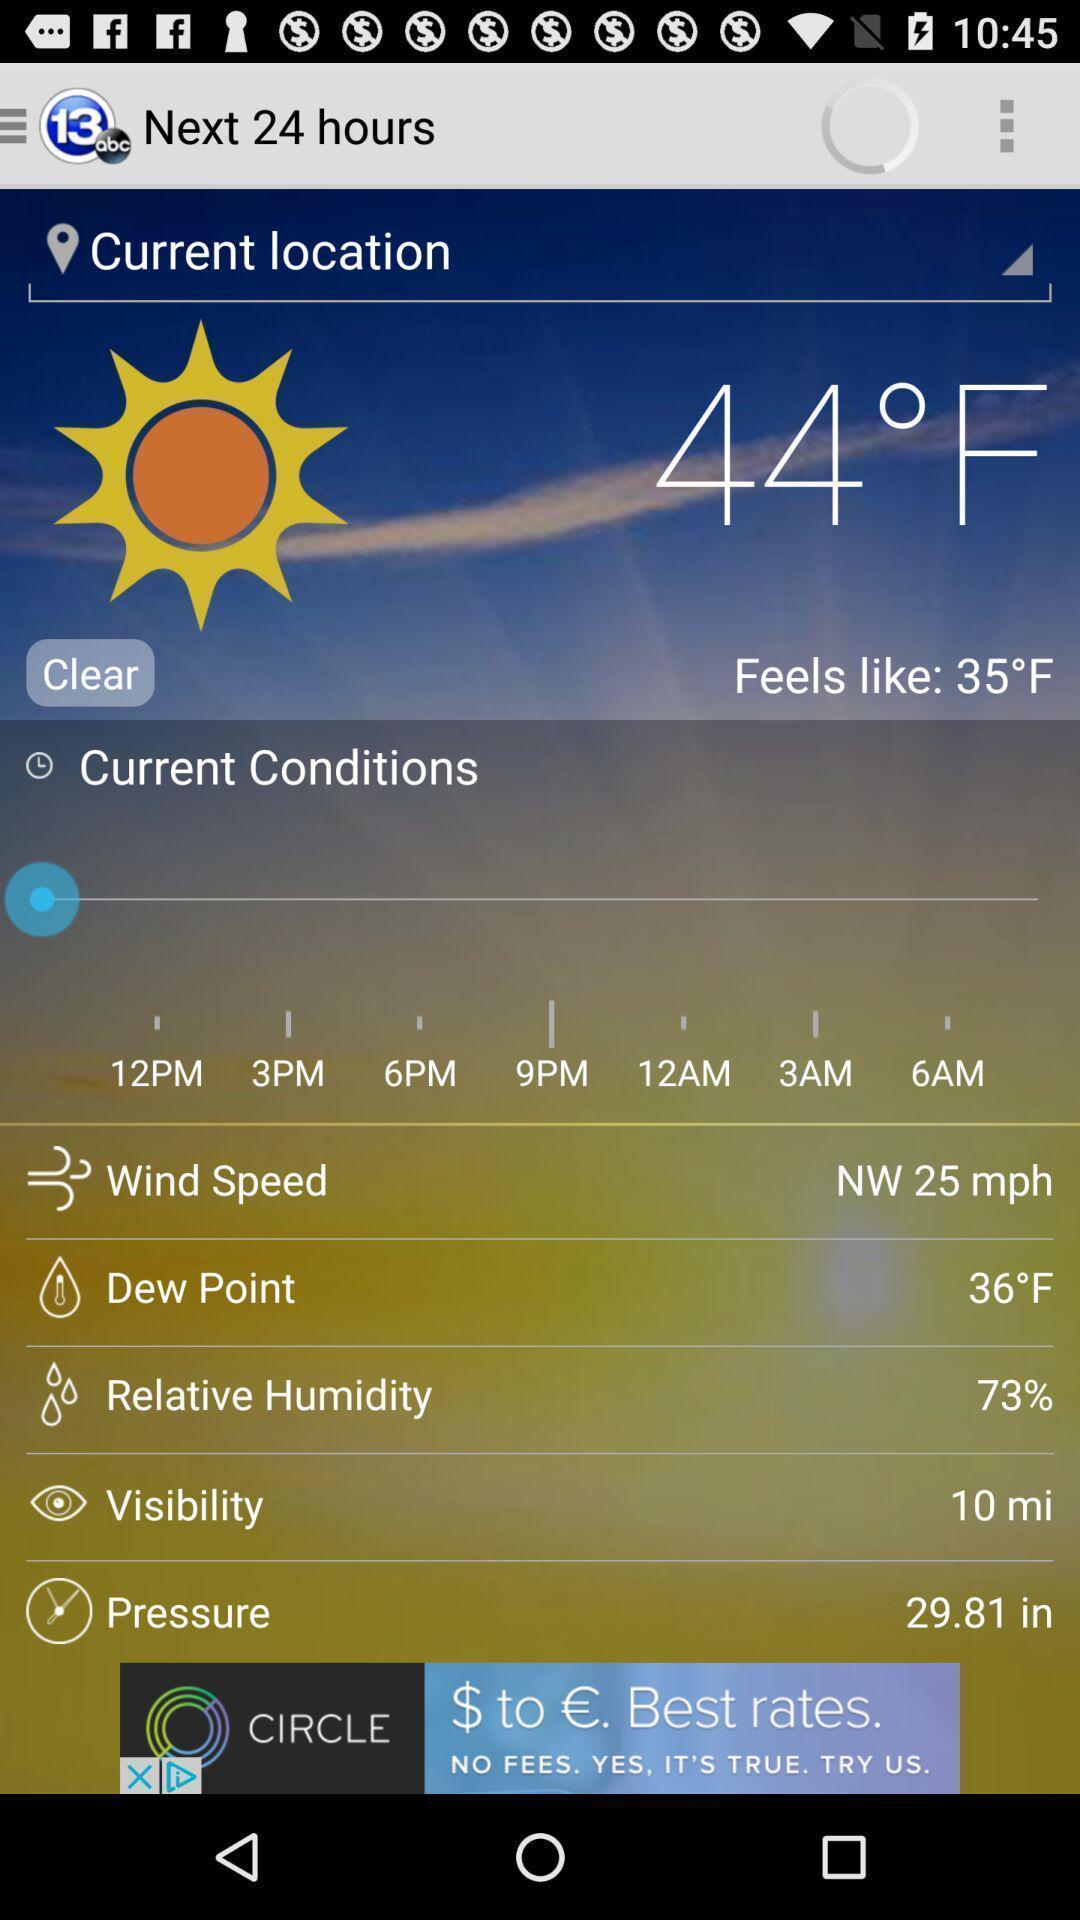Summarize the main components in this picture. Weather status showing in this page. 